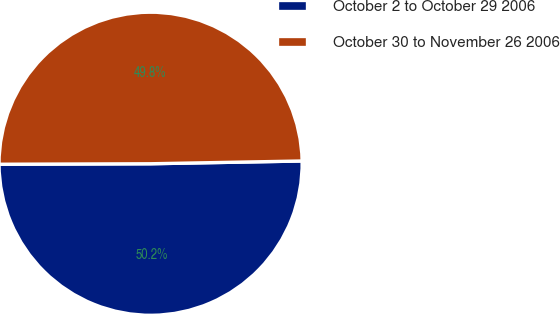Convert chart to OTSL. <chart><loc_0><loc_0><loc_500><loc_500><pie_chart><fcel>October 2 to October 29 2006<fcel>October 30 to November 26 2006<nl><fcel>50.24%<fcel>49.76%<nl></chart> 